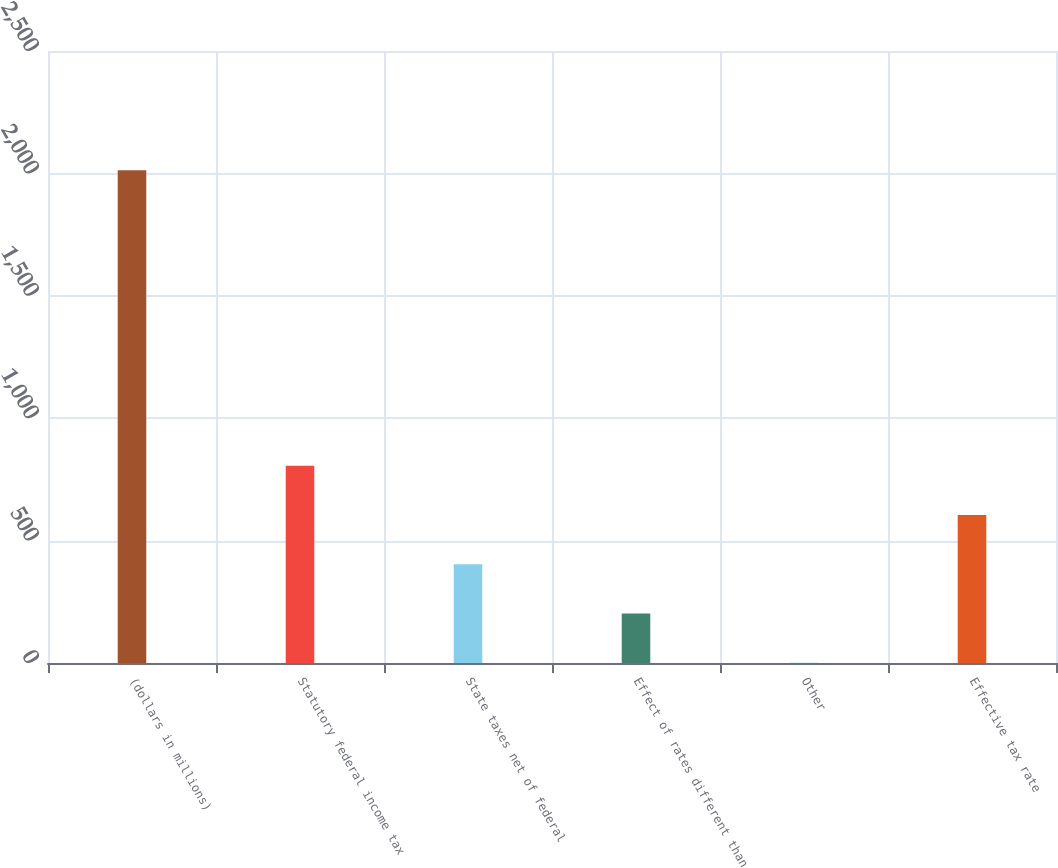Convert chart. <chart><loc_0><loc_0><loc_500><loc_500><bar_chart><fcel>(dollars in millions)<fcel>Statutory federal income tax<fcel>State taxes net of federal<fcel>Effect of rates different than<fcel>Other<fcel>Effective tax rate<nl><fcel>2013<fcel>805.62<fcel>403.16<fcel>201.93<fcel>0.7<fcel>604.39<nl></chart> 